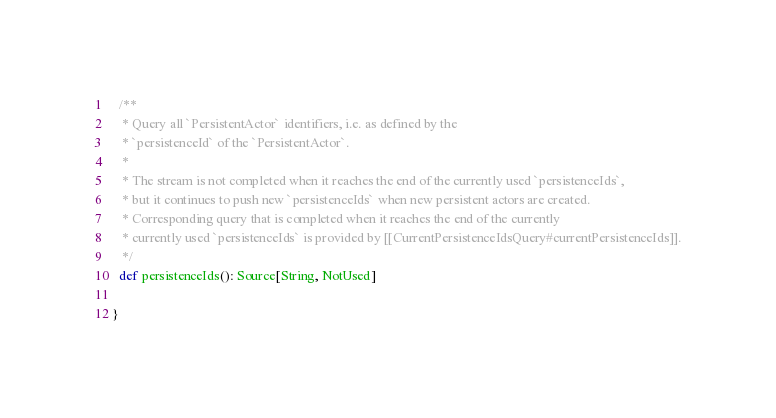<code> <loc_0><loc_0><loc_500><loc_500><_Scala_>
  /**
   * Query all `PersistentActor` identifiers, i.e. as defined by the
   * `persistenceId` of the `PersistentActor`.
   *
   * The stream is not completed when it reaches the end of the currently used `persistenceIds`,
   * but it continues to push new `persistenceIds` when new persistent actors are created.
   * Corresponding query that is completed when it reaches the end of the currently
   * currently used `persistenceIds` is provided by [[CurrentPersistenceIdsQuery#currentPersistenceIds]].
   */
  def persistenceIds(): Source[String, NotUsed]

}
</code> 